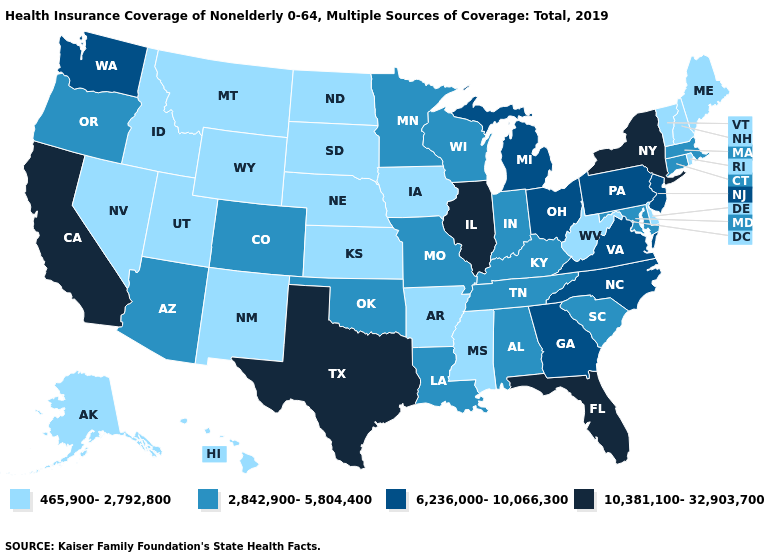Name the states that have a value in the range 10,381,100-32,903,700?
Quick response, please. California, Florida, Illinois, New York, Texas. Which states have the lowest value in the West?
Write a very short answer. Alaska, Hawaii, Idaho, Montana, Nevada, New Mexico, Utah, Wyoming. What is the lowest value in states that border Kentucky?
Give a very brief answer. 465,900-2,792,800. What is the lowest value in the USA?
Concise answer only. 465,900-2,792,800. Is the legend a continuous bar?
Be succinct. No. What is the value of Texas?
Be succinct. 10,381,100-32,903,700. Does Illinois have the highest value in the MidWest?
Answer briefly. Yes. Among the states that border Colorado , which have the highest value?
Concise answer only. Arizona, Oklahoma. Name the states that have a value in the range 465,900-2,792,800?
Quick response, please. Alaska, Arkansas, Delaware, Hawaii, Idaho, Iowa, Kansas, Maine, Mississippi, Montana, Nebraska, Nevada, New Hampshire, New Mexico, North Dakota, Rhode Island, South Dakota, Utah, Vermont, West Virginia, Wyoming. Name the states that have a value in the range 2,842,900-5,804,400?
Answer briefly. Alabama, Arizona, Colorado, Connecticut, Indiana, Kentucky, Louisiana, Maryland, Massachusetts, Minnesota, Missouri, Oklahoma, Oregon, South Carolina, Tennessee, Wisconsin. Among the states that border North Dakota , does Minnesota have the highest value?
Give a very brief answer. Yes. Among the states that border New Hampshire , which have the lowest value?
Short answer required. Maine, Vermont. What is the value of New Mexico?
Quick response, please. 465,900-2,792,800. Name the states that have a value in the range 10,381,100-32,903,700?
Give a very brief answer. California, Florida, Illinois, New York, Texas. Name the states that have a value in the range 465,900-2,792,800?
Short answer required. Alaska, Arkansas, Delaware, Hawaii, Idaho, Iowa, Kansas, Maine, Mississippi, Montana, Nebraska, Nevada, New Hampshire, New Mexico, North Dakota, Rhode Island, South Dakota, Utah, Vermont, West Virginia, Wyoming. 